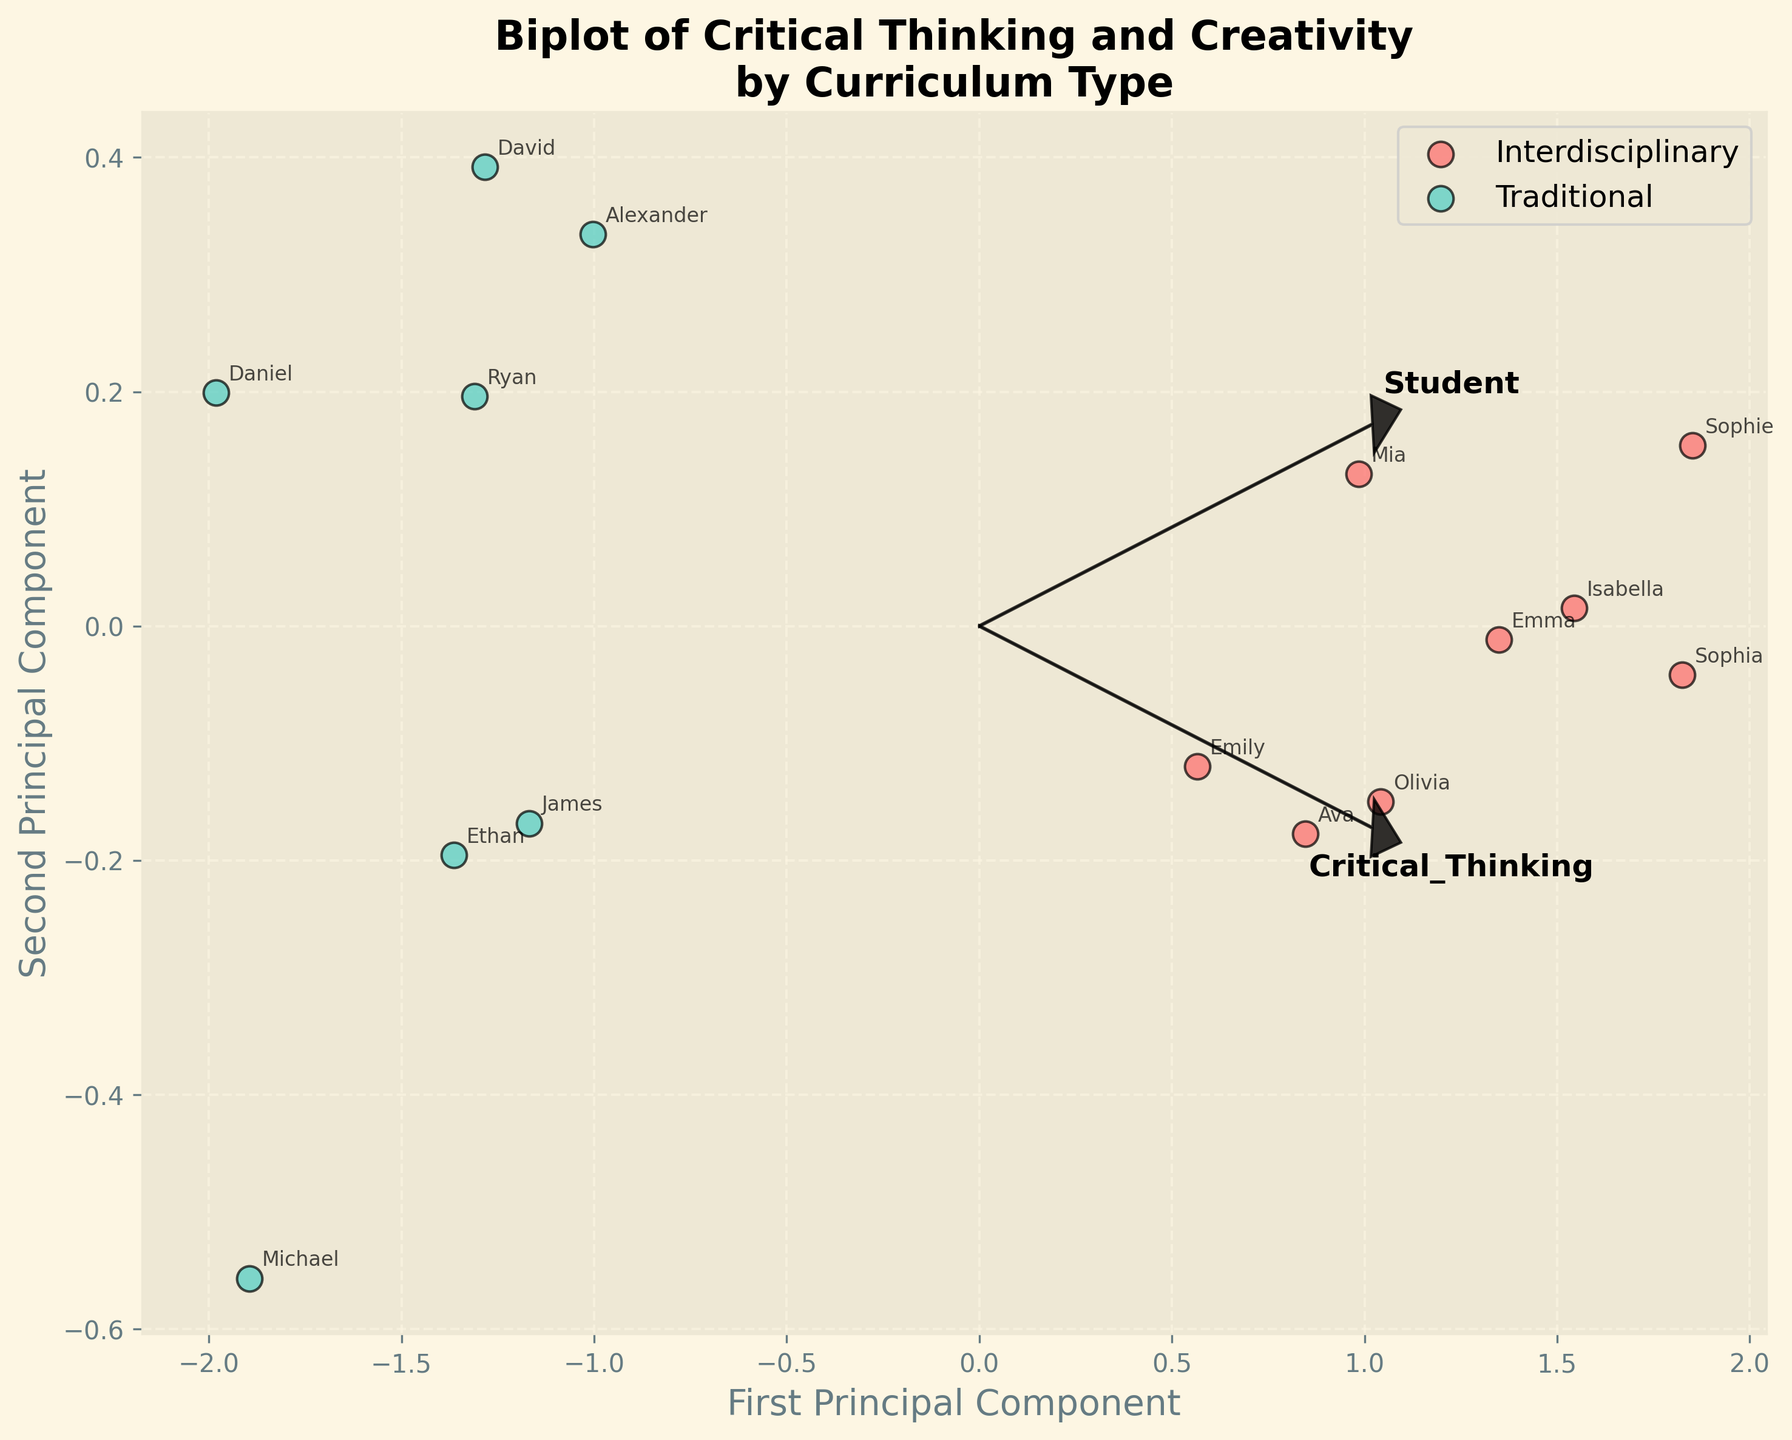What is the main purpose of the biplot? The biplot aims to visually compare students' critical thinking abilities and creativity scores between traditional and interdisciplinary curricula using principal component analysis.
Answer: To compare critical thinking and creativity scores between curricula What colors represent the two curriculum types in the biplot? The colors differentiate the curriculum types, with interdisciplinary curricula shown in red and traditional curricula in green.
Answer: Red and green How does the loadings plot for critical thinking and creativity appear on the biplot? The loadings are represented as arrows pointing from the origin, where critical thinking and creativity loadings indicate their contribution to the principal components.
Answer: Arrows from origin Which curriculum type shows higher clustering around higher values of the principal components? Observations for interdisciplinary curricula tend to cluster around higher values of the first and second principal components.
Answer: Interdisciplinary Do any students overlap in their positions on the biplot? No students appear to overlap exactly, though some may be positioned closely to one another.
Answer: No Which axis has a greater variability or spread? The first principal component shows greater variability or spread compared to the second principal component.
Answer: First principal component What can the length and direction of the arrows in the loadings tell us? They show the direction and relative importance of each variable (critical thinking and creativity) and indicate how much each contributes to the principal components.
Answer: Direction and importance of variables Who are the students with the highest critical thinking and creativity scores based on the biplot? The students positioned farthest in the direction of the arrows for critical thinking and creativity, such as Sophie and Sophia.
Answer: Sophie and Sophia Compare the relative proportions of variance explained by the first and second principal components. Principal component 1 explains more variance than principal component 2, evident by the greater spread along the first axis.
Answer: Principal component 1 explains more 